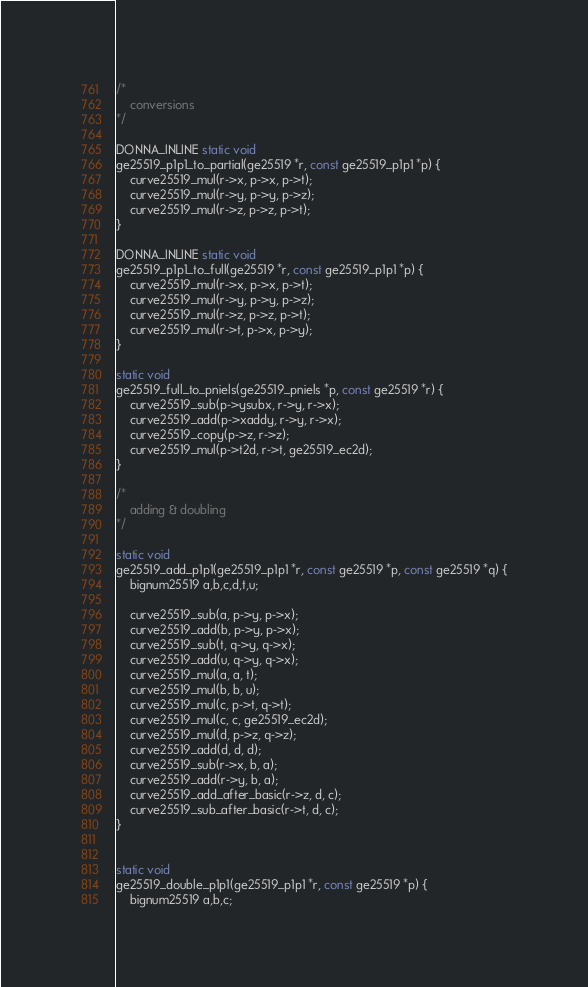Convert code to text. <code><loc_0><loc_0><loc_500><loc_500><_C_>/*
	conversions
*/

DONNA_INLINE static void
ge25519_p1p1_to_partial(ge25519 *r, const ge25519_p1p1 *p) {
	curve25519_mul(r->x, p->x, p->t);
	curve25519_mul(r->y, p->y, p->z);
	curve25519_mul(r->z, p->z, p->t); 
}

DONNA_INLINE static void
ge25519_p1p1_to_full(ge25519 *r, const ge25519_p1p1 *p) {
	curve25519_mul(r->x, p->x, p->t);
	curve25519_mul(r->y, p->y, p->z);
	curve25519_mul(r->z, p->z, p->t); 
	curve25519_mul(r->t, p->x, p->y); 
}

static void
ge25519_full_to_pniels(ge25519_pniels *p, const ge25519 *r) {
	curve25519_sub(p->ysubx, r->y, r->x);
	curve25519_add(p->xaddy, r->y, r->x);
	curve25519_copy(p->z, r->z);
	curve25519_mul(p->t2d, r->t, ge25519_ec2d);
}

/*
	adding & doubling
*/

static void
ge25519_add_p1p1(ge25519_p1p1 *r, const ge25519 *p, const ge25519 *q) {
	bignum25519 a,b,c,d,t,u;

	curve25519_sub(a, p->y, p->x);
	curve25519_add(b, p->y, p->x);
	curve25519_sub(t, q->y, q->x);
	curve25519_add(u, q->y, q->x);
	curve25519_mul(a, a, t);
	curve25519_mul(b, b, u);
	curve25519_mul(c, p->t, q->t);
	curve25519_mul(c, c, ge25519_ec2d);
	curve25519_mul(d, p->z, q->z);
	curve25519_add(d, d, d);
	curve25519_sub(r->x, b, a);
	curve25519_add(r->y, b, a);
	curve25519_add_after_basic(r->z, d, c);
	curve25519_sub_after_basic(r->t, d, c);
}


static void
ge25519_double_p1p1(ge25519_p1p1 *r, const ge25519 *p) {
	bignum25519 a,b,c;
</code> 